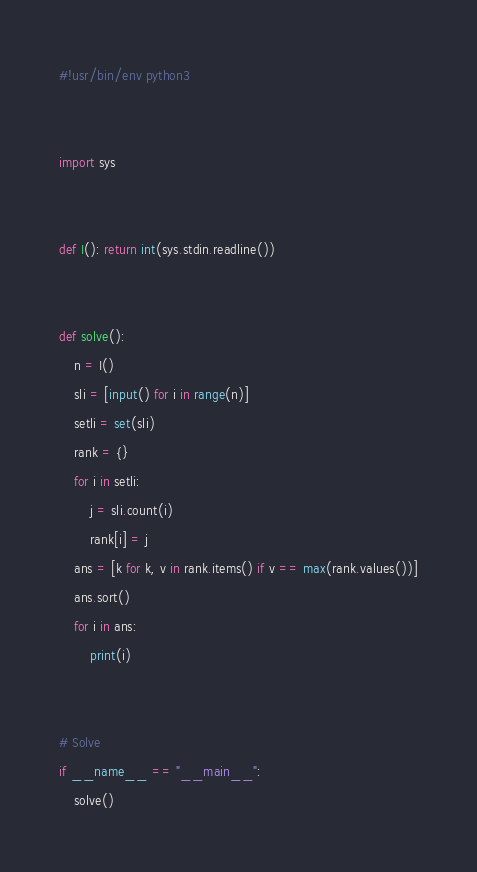<code> <loc_0><loc_0><loc_500><loc_500><_Python_>#!usr/bin/env python3


import sys


def I(): return int(sys.stdin.readline())


def solve():
    n = I()
    sli = [input() for i in range(n)]
    setli = set(sli)
    rank = {}
    for i in setli:
        j = sli.count(i)
        rank[i] = j
    ans = [k for k, v in rank.items() if v == max(rank.values())]
    ans.sort()
    for i in ans:
        print(i)


# Solve
if __name__ == "__main__":
    solve()
</code> 